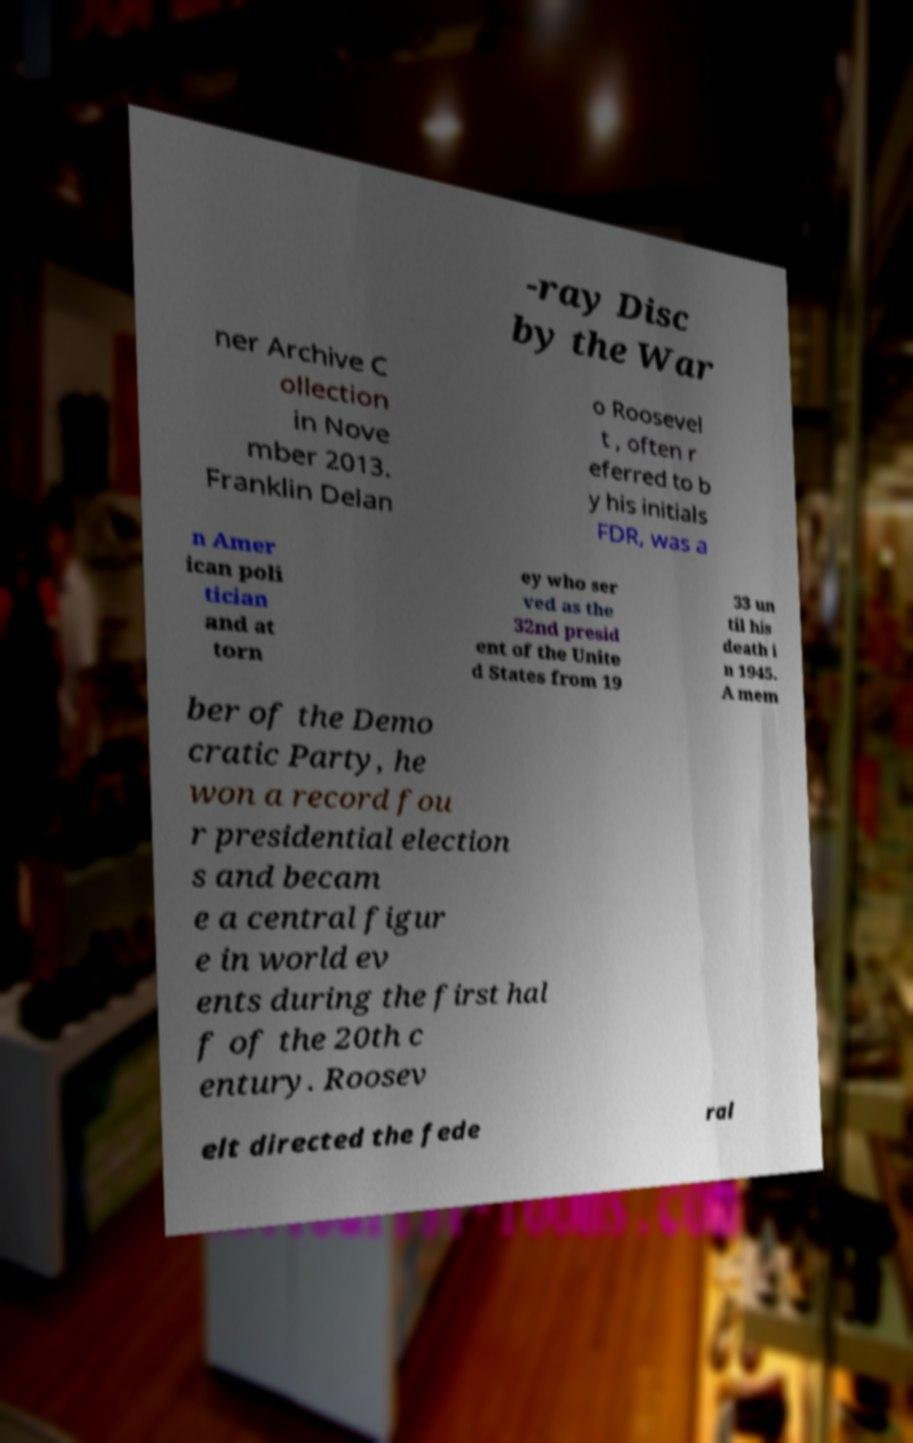I need the written content from this picture converted into text. Can you do that? -ray Disc by the War ner Archive C ollection in Nove mber 2013. Franklin Delan o Roosevel t , often r eferred to b y his initials FDR, was a n Amer ican poli tician and at torn ey who ser ved as the 32nd presid ent of the Unite d States from 19 33 un til his death i n 1945. A mem ber of the Demo cratic Party, he won a record fou r presidential election s and becam e a central figur e in world ev ents during the first hal f of the 20th c entury. Roosev elt directed the fede ral 